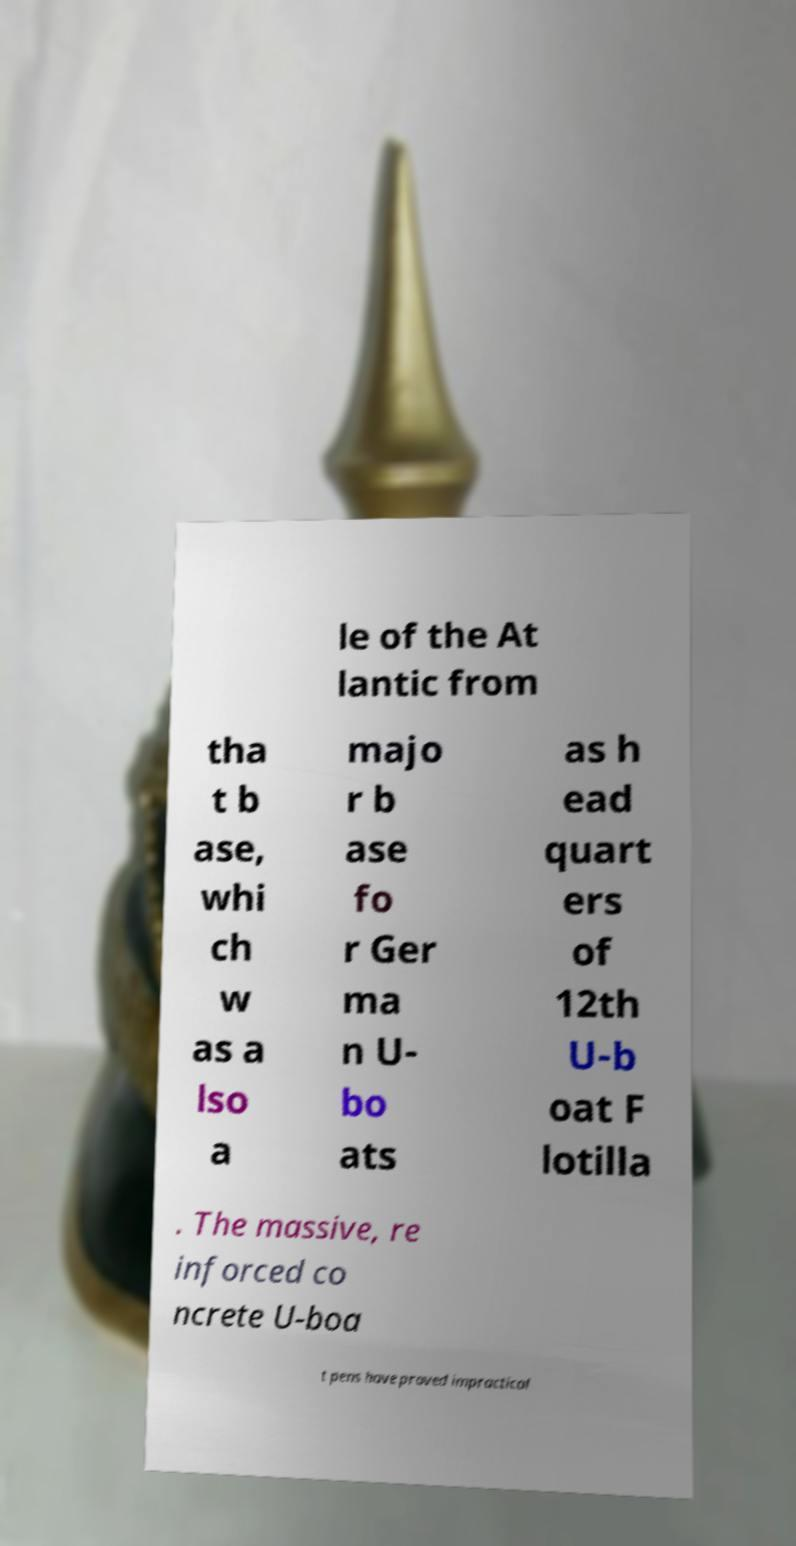Can you accurately transcribe the text from the provided image for me? le of the At lantic from tha t b ase, whi ch w as a lso a majo r b ase fo r Ger ma n U- bo ats as h ead quart ers of 12th U-b oat F lotilla . The massive, re inforced co ncrete U-boa t pens have proved impractical 